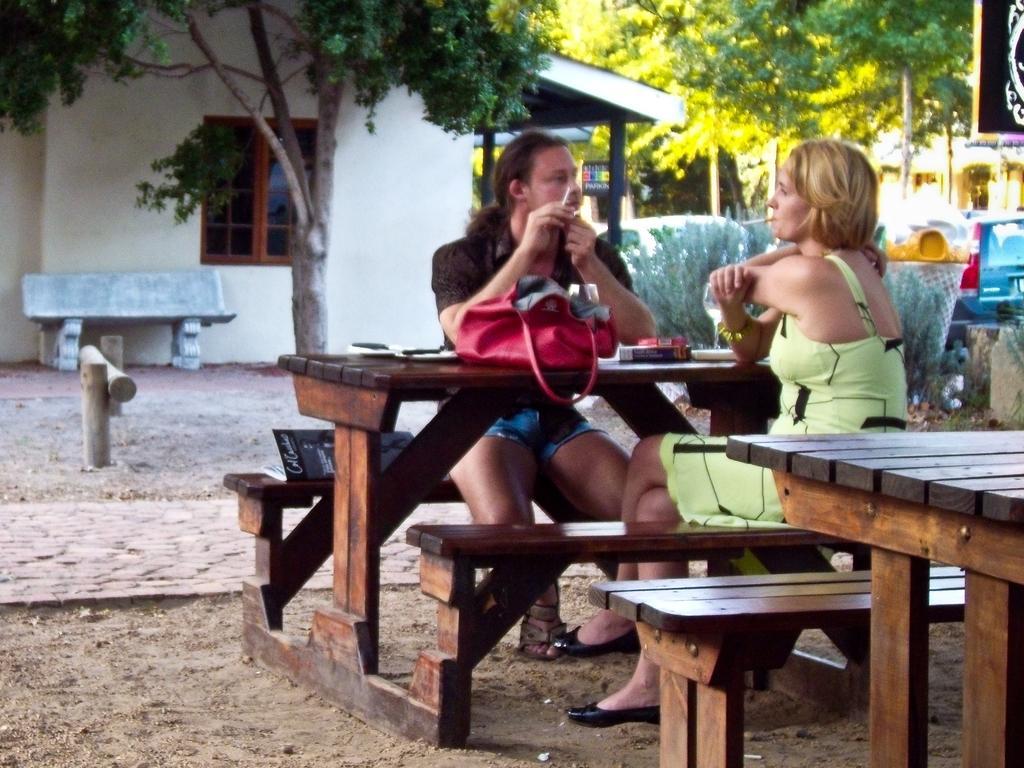How would you summarize this image in a sentence or two? In the image there is a man and woman sat opposite to each other on a bench and in the background there is a home,in front of home there is a tree and there are tree on right side top corner,on the floor it's mud,gravel. 